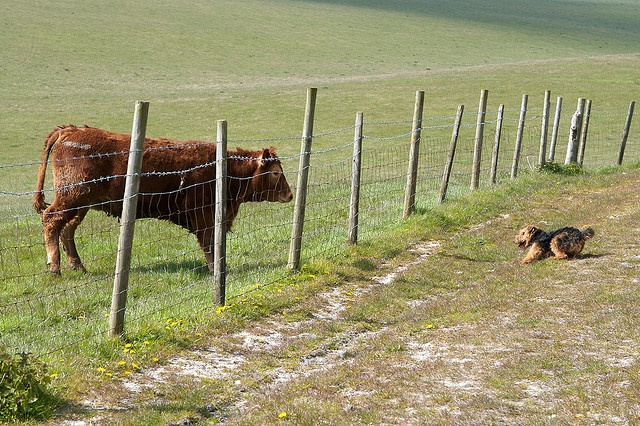Describe the objects in this image and their specific colors. I can see cow in tan, black, maroon, and brown tones and dog in tan, black, gray, and maroon tones in this image. 